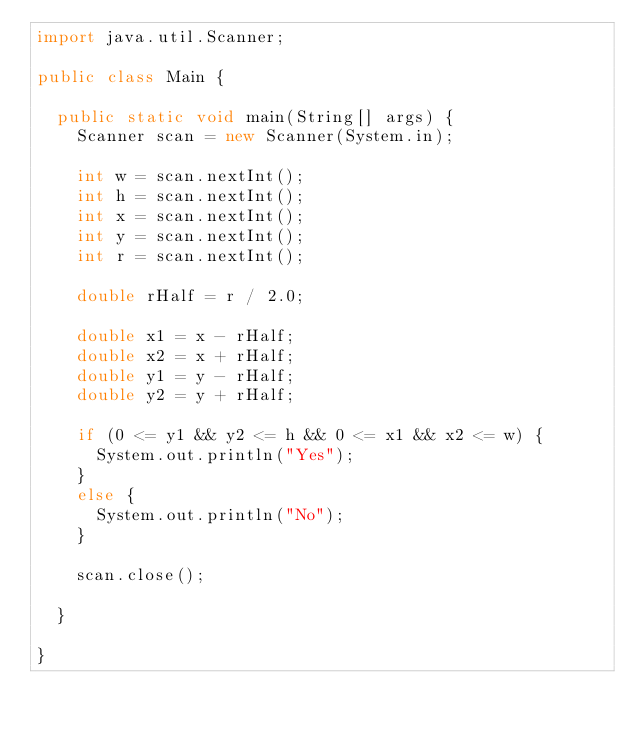Convert code to text. <code><loc_0><loc_0><loc_500><loc_500><_Java_>import java.util.Scanner;

public class Main {

	public static void main(String[] args) {
		Scanner scan = new Scanner(System.in);		
		
		int w = scan.nextInt();
		int h = scan.nextInt();
		int x = scan.nextInt();
		int y = scan.nextInt();
		int r = scan.nextInt();

		double rHalf = r / 2.0;
		
		double x1 = x - rHalf;
		double x2 = x + rHalf;
		double y1 = y - rHalf;
		double y2 = y + rHalf;

		if (0 <= y1 && y2 <= h && 0 <= x1 && x2 <= w) {
			System.out.println("Yes");
		}
		else {
			System.out.println("No");
		}
			
		scan.close();

	}

}</code> 